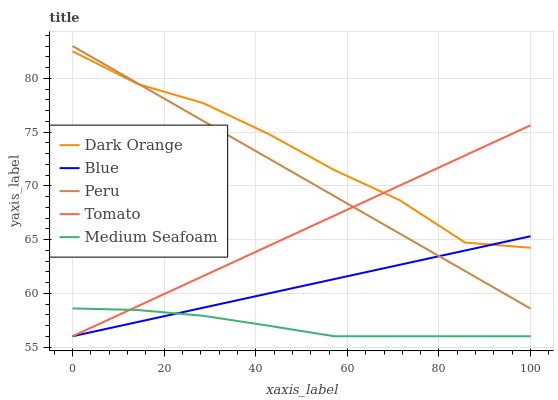Does Medium Seafoam have the minimum area under the curve?
Answer yes or no. Yes. Does Dark Orange have the maximum area under the curve?
Answer yes or no. Yes. Does Tomato have the minimum area under the curve?
Answer yes or no. No. Does Tomato have the maximum area under the curve?
Answer yes or no. No. Is Blue the smoothest?
Answer yes or no. Yes. Is Dark Orange the roughest?
Answer yes or no. Yes. Is Tomato the smoothest?
Answer yes or no. No. Is Tomato the roughest?
Answer yes or no. No. Does Blue have the lowest value?
Answer yes or no. Yes. Does Dark Orange have the lowest value?
Answer yes or no. No. Does Peru have the highest value?
Answer yes or no. Yes. Does Dark Orange have the highest value?
Answer yes or no. No. Is Medium Seafoam less than Dark Orange?
Answer yes or no. Yes. Is Peru greater than Medium Seafoam?
Answer yes or no. Yes. Does Blue intersect Peru?
Answer yes or no. Yes. Is Blue less than Peru?
Answer yes or no. No. Is Blue greater than Peru?
Answer yes or no. No. Does Medium Seafoam intersect Dark Orange?
Answer yes or no. No. 